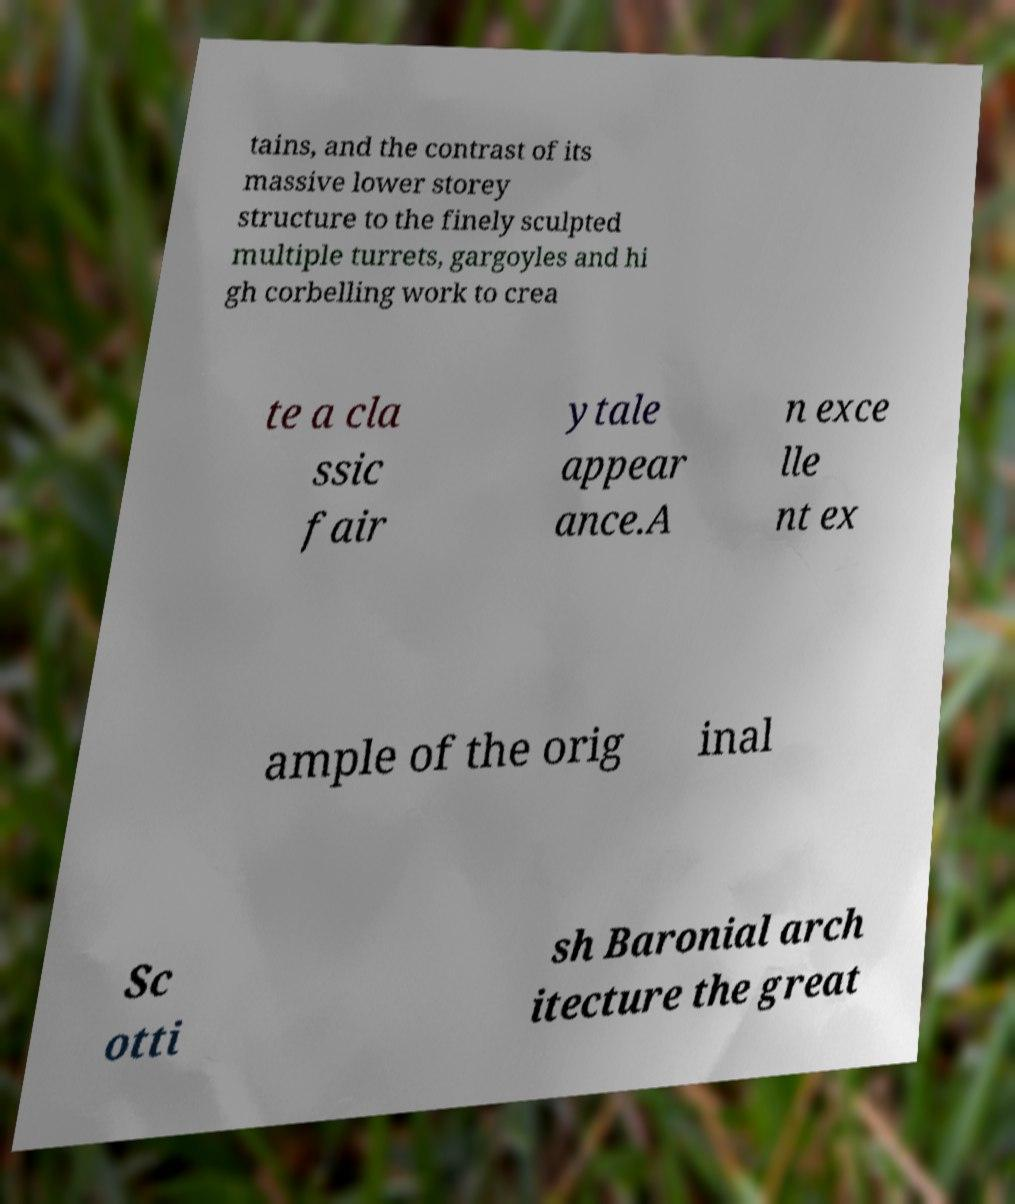For documentation purposes, I need the text within this image transcribed. Could you provide that? tains, and the contrast of its massive lower storey structure to the finely sculpted multiple turrets, gargoyles and hi gh corbelling work to crea te a cla ssic fair ytale appear ance.A n exce lle nt ex ample of the orig inal Sc otti sh Baronial arch itecture the great 